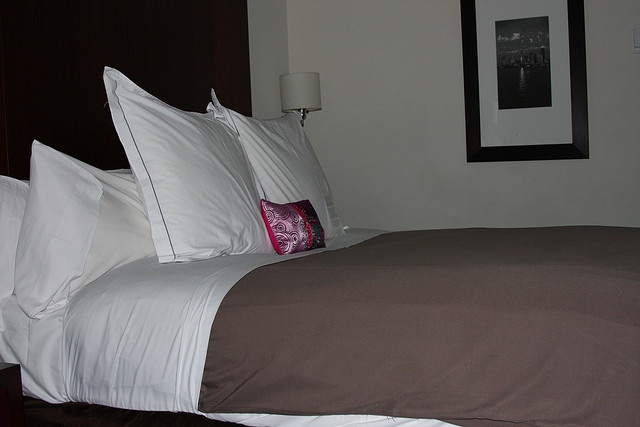Describe the objects in this image and their specific colors. I can see a bed in black, gray, and darkgray tones in this image. 